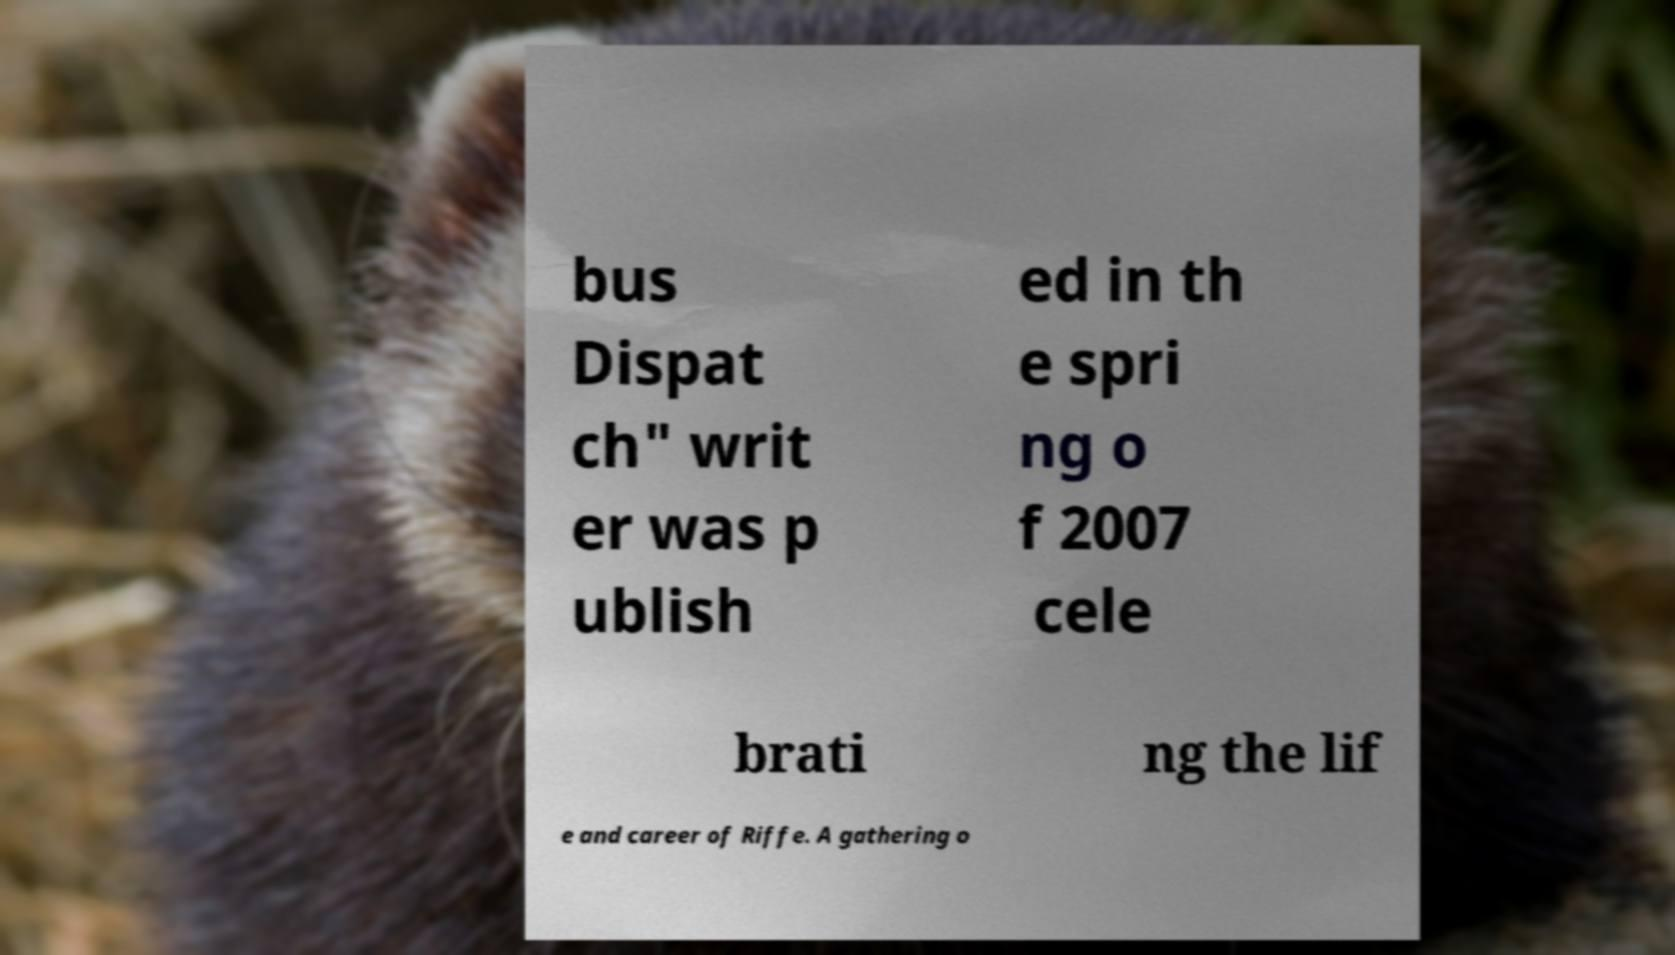Can you accurately transcribe the text from the provided image for me? bus Dispat ch" writ er was p ublish ed in th e spri ng o f 2007 cele brati ng the lif e and career of Riffe. A gathering o 